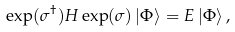<formula> <loc_0><loc_0><loc_500><loc_500>\exp ( \sigma ^ { \dagger } ) H \exp ( \sigma ) \left | \Phi \right \rangle = E \left | \Phi \right \rangle ,</formula> 